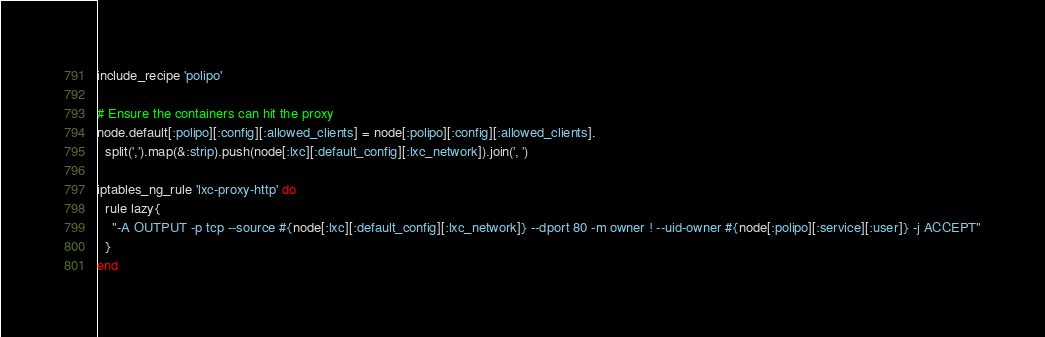<code> <loc_0><loc_0><loc_500><loc_500><_Ruby_>include_recipe 'polipo'

# Ensure the containers can hit the proxy
node.default[:polipo][:config][:allowed_clients] = node[:polipo][:config][:allowed_clients].
  split(',').map(&:strip).push(node[:lxc][:default_config][:lxc_network]).join(', ')

iptables_ng_rule 'lxc-proxy-http' do
  rule lazy{
    "-A OUTPUT -p tcp --source #{node[:lxc][:default_config][:lxc_network]} --dport 80 -m owner ! --uid-owner #{node[:polipo][:service][:user]} -j ACCEPT"
  }
end
</code> 